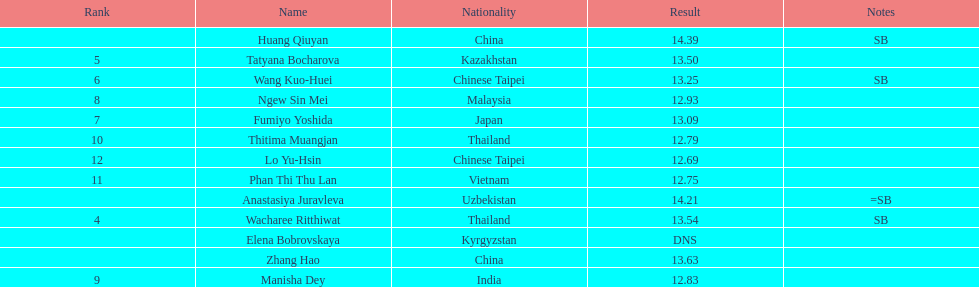Which country had the most competitors ranked in the top three in the event? China. Parse the full table. {'header': ['Rank', 'Name', 'Nationality', 'Result', 'Notes'], 'rows': [['', 'Huang Qiuyan', 'China', '14.39', 'SB'], ['5', 'Tatyana Bocharova', 'Kazakhstan', '13.50', ''], ['6', 'Wang Kuo-Huei', 'Chinese Taipei', '13.25', 'SB'], ['8', 'Ngew Sin Mei', 'Malaysia', '12.93', ''], ['7', 'Fumiyo Yoshida', 'Japan', '13.09', ''], ['10', 'Thitima Muangjan', 'Thailand', '12.79', ''], ['12', 'Lo Yu-Hsin', 'Chinese Taipei', '12.69', ''], ['11', 'Phan Thi Thu Lan', 'Vietnam', '12.75', ''], ['', 'Anastasiya Juravleva', 'Uzbekistan', '14.21', '=SB'], ['4', 'Wacharee Ritthiwat', 'Thailand', '13.54', 'SB'], ['', 'Elena Bobrovskaya', 'Kyrgyzstan', 'DNS', ''], ['', 'Zhang Hao', 'China', '13.63', ''], ['9', 'Manisha Dey', 'India', '12.83', '']]} 